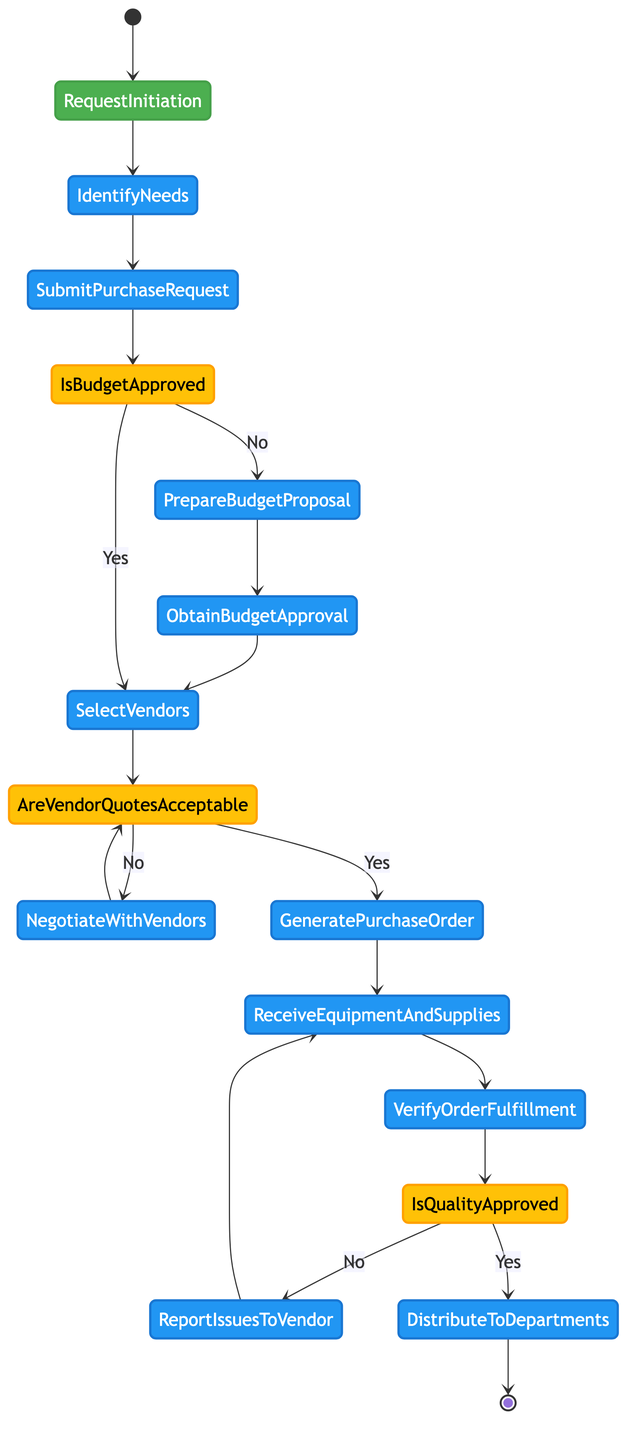What is the first action in the procurement process? The first action is "Identify Needs," which follows the "Request Initiation" event in the diagram.
Answer: Identify Needs How many decision nodes are in the diagram? There are three decision nodes: "Is Budget Approved?", "Are Vendor Quotes Acceptable?", and "Is Quality Approved?" counted as individual nodes.
Answer: 3 What action follows "Submit Purchase Request" if the budget is not approved? If the budget is not approved, the next action is "Prepare Budget Proposal," which prepares and submits a budget proposal for approval.
Answer: Prepare Budget Proposal What happens if vendor quotes are not acceptable? If vendor quotes are not acceptable, the process goes to "Negotiate with Vendors," where the terms and prices are negotiated.
Answer: Negotiate with Vendors What is the outcome if the quality of received items is approved? If the quality of received items is approved, the next action is "Distribute to Departments," meaning the items will be distributed to their respective departments after approval.
Answer: Distribute to Departments What action involves receiving and inspecting delivered items? The action that involves receiving and inspecting the delivered items from the vendors is "Receive Equipment and Supplies."
Answer: Receive Equipment and Supplies What node connects "Obtain Budget Approval" to "Select Vendors"? The connecting node is "Is Budget Approved?" which leads to "Select Vendors" if the budget is approved (Yes).
Answer: Is Budget Approved? How do you handle discrepancies found in received items? If discrepancies are found, the process leads to "Report Issues to Vendor," where the issues are reported and replacements requested if necessary.
Answer: Report Issues to Vendor 